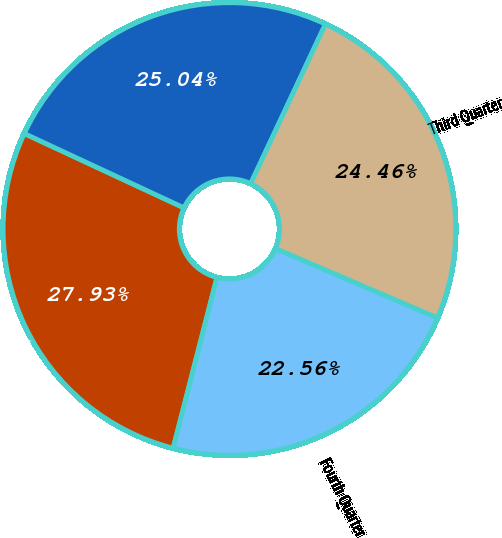<chart> <loc_0><loc_0><loc_500><loc_500><pie_chart><fcel>First Quarter<fcel>Second Quarter<fcel>Third Quarter<fcel>Fourth Quarter<nl><fcel>27.93%<fcel>25.04%<fcel>24.46%<fcel>22.56%<nl></chart> 